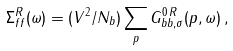<formula> <loc_0><loc_0><loc_500><loc_500>\Sigma _ { f f } ^ { R } ( \omega ) = ( V ^ { 2 } / N _ { b } ) \sum _ { p } G _ { b b , \sigma } ^ { 0 \, R } ( p , \omega ) \, ,</formula> 